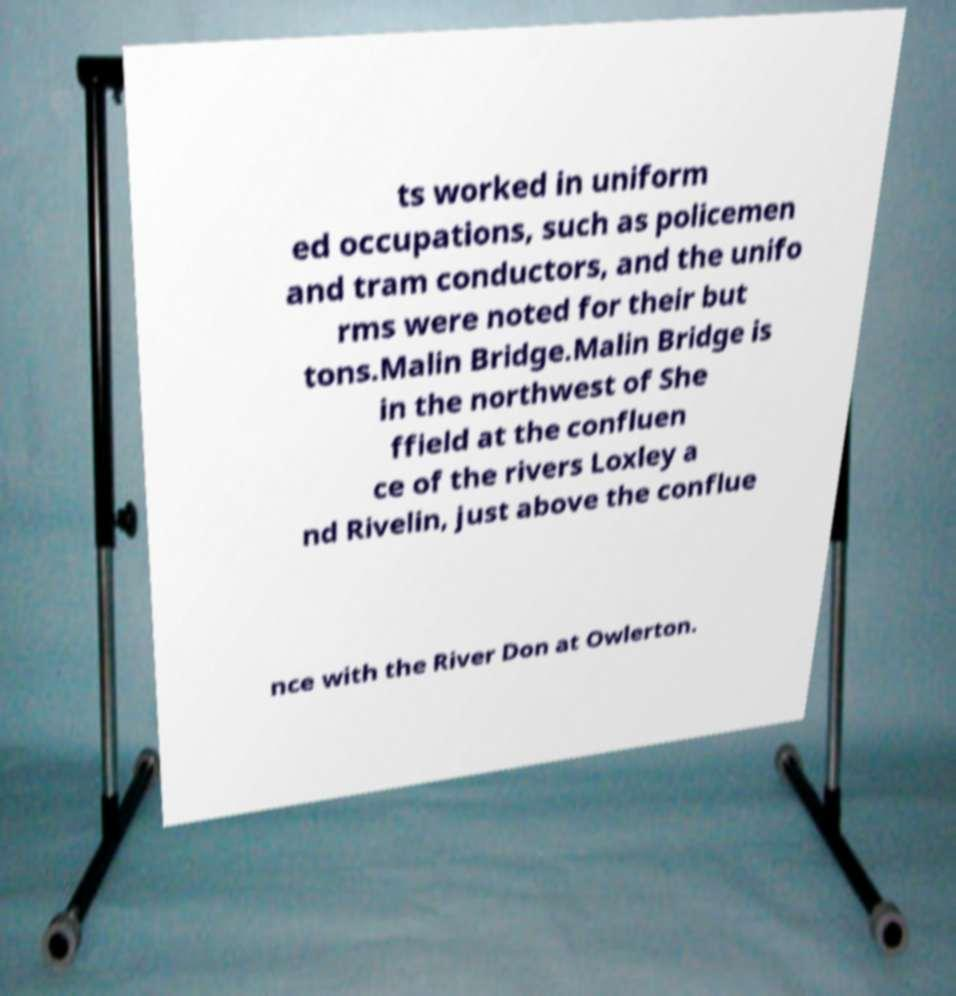What messages or text are displayed in this image? I need them in a readable, typed format. ts worked in uniform ed occupations, such as policemen and tram conductors, and the unifo rms were noted for their but tons.Malin Bridge.Malin Bridge is in the northwest of She ffield at the confluen ce of the rivers Loxley a nd Rivelin, just above the conflue nce with the River Don at Owlerton. 